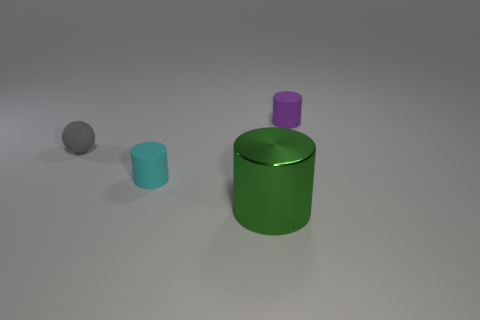Add 1 big green blocks. How many objects exist? 5 Subtract all cylinders. How many objects are left? 1 Subtract 0 brown spheres. How many objects are left? 4 Subtract all red metal cubes. Subtract all tiny matte cylinders. How many objects are left? 2 Add 3 matte cylinders. How many matte cylinders are left? 5 Add 3 tiny purple rubber objects. How many tiny purple rubber objects exist? 4 